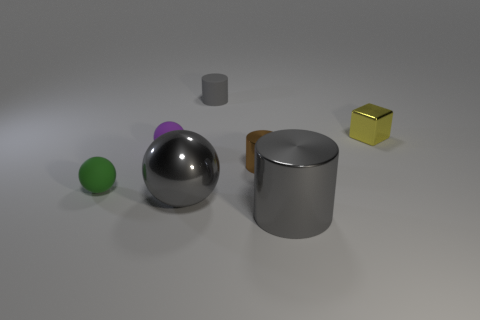The tiny object that is in front of the purple rubber object and to the left of the gray sphere is made of what material?
Provide a succinct answer. Rubber. Are there any other small matte objects that have the same shape as the purple object?
Provide a short and direct response. Yes. There is a small cylinder that is in front of the small gray cylinder; is there a small yellow block in front of it?
Provide a succinct answer. No. What number of large purple blocks have the same material as the big ball?
Keep it short and to the point. 0. Is there a gray matte object?
Make the answer very short. Yes. How many large cylinders are the same color as the small rubber cylinder?
Your answer should be compact. 1. Do the tiny purple thing and the tiny cylinder that is behind the tiny yellow thing have the same material?
Your answer should be compact. Yes. Is the number of small green balls that are to the right of the purple thing greater than the number of brown things?
Your answer should be compact. No. There is a big metallic sphere; is it the same color as the tiny matte sphere in front of the tiny brown metallic cylinder?
Give a very brief answer. No. Is the number of balls that are to the right of the gray rubber cylinder the same as the number of tiny gray cylinders behind the tiny purple matte thing?
Your response must be concise. No. 